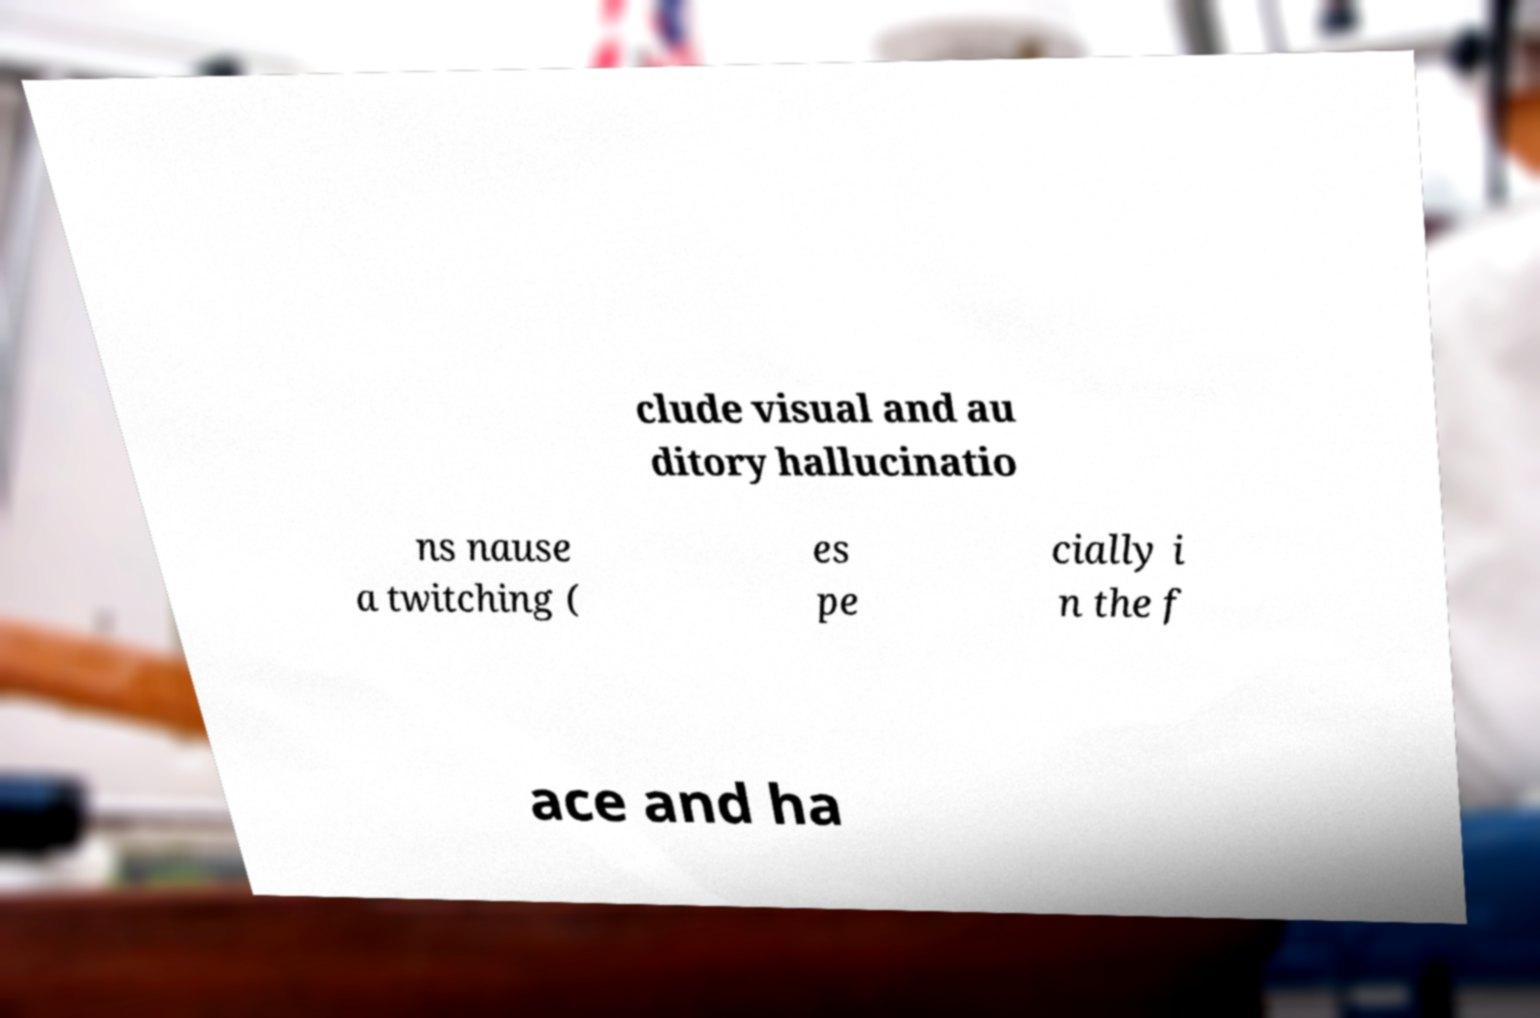Can you accurately transcribe the text from the provided image for me? clude visual and au ditory hallucinatio ns nause a twitching ( es pe cially i n the f ace and ha 